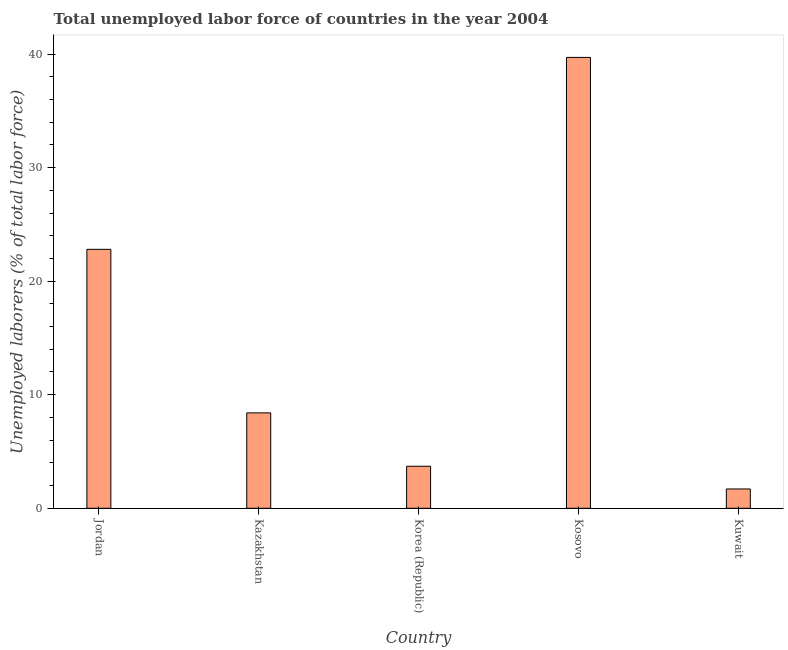What is the title of the graph?
Provide a short and direct response. Total unemployed labor force of countries in the year 2004. What is the label or title of the X-axis?
Provide a succinct answer. Country. What is the label or title of the Y-axis?
Keep it short and to the point. Unemployed laborers (% of total labor force). What is the total unemployed labour force in Kazakhstan?
Provide a succinct answer. 8.4. Across all countries, what is the maximum total unemployed labour force?
Make the answer very short. 39.7. Across all countries, what is the minimum total unemployed labour force?
Provide a short and direct response. 1.7. In which country was the total unemployed labour force maximum?
Your answer should be very brief. Kosovo. In which country was the total unemployed labour force minimum?
Your answer should be compact. Kuwait. What is the sum of the total unemployed labour force?
Offer a terse response. 76.3. What is the average total unemployed labour force per country?
Your answer should be compact. 15.26. What is the median total unemployed labour force?
Make the answer very short. 8.4. What is the ratio of the total unemployed labour force in Korea (Republic) to that in Kosovo?
Your answer should be very brief. 0.09. Is the difference between the total unemployed labour force in Kazakhstan and Kosovo greater than the difference between any two countries?
Make the answer very short. No. What is the difference between the highest and the second highest total unemployed labour force?
Offer a terse response. 16.9. Is the sum of the total unemployed labour force in Kosovo and Kuwait greater than the maximum total unemployed labour force across all countries?
Ensure brevity in your answer.  Yes. How many bars are there?
Offer a terse response. 5. Are all the bars in the graph horizontal?
Make the answer very short. No. What is the difference between two consecutive major ticks on the Y-axis?
Provide a short and direct response. 10. What is the Unemployed laborers (% of total labor force) of Jordan?
Offer a very short reply. 22.8. What is the Unemployed laborers (% of total labor force) in Kazakhstan?
Offer a very short reply. 8.4. What is the Unemployed laborers (% of total labor force) of Korea (Republic)?
Your response must be concise. 3.7. What is the Unemployed laborers (% of total labor force) in Kosovo?
Make the answer very short. 39.7. What is the Unemployed laborers (% of total labor force) in Kuwait?
Your response must be concise. 1.7. What is the difference between the Unemployed laborers (% of total labor force) in Jordan and Kosovo?
Provide a succinct answer. -16.9. What is the difference between the Unemployed laborers (% of total labor force) in Jordan and Kuwait?
Your answer should be compact. 21.1. What is the difference between the Unemployed laborers (% of total labor force) in Kazakhstan and Korea (Republic)?
Your answer should be compact. 4.7. What is the difference between the Unemployed laborers (% of total labor force) in Kazakhstan and Kosovo?
Give a very brief answer. -31.3. What is the difference between the Unemployed laborers (% of total labor force) in Kazakhstan and Kuwait?
Provide a short and direct response. 6.7. What is the difference between the Unemployed laborers (% of total labor force) in Korea (Republic) and Kosovo?
Your response must be concise. -36. What is the ratio of the Unemployed laborers (% of total labor force) in Jordan to that in Kazakhstan?
Your answer should be compact. 2.71. What is the ratio of the Unemployed laborers (% of total labor force) in Jordan to that in Korea (Republic)?
Your answer should be compact. 6.16. What is the ratio of the Unemployed laborers (% of total labor force) in Jordan to that in Kosovo?
Offer a terse response. 0.57. What is the ratio of the Unemployed laborers (% of total labor force) in Jordan to that in Kuwait?
Provide a short and direct response. 13.41. What is the ratio of the Unemployed laborers (% of total labor force) in Kazakhstan to that in Korea (Republic)?
Provide a short and direct response. 2.27. What is the ratio of the Unemployed laborers (% of total labor force) in Kazakhstan to that in Kosovo?
Your answer should be compact. 0.21. What is the ratio of the Unemployed laborers (% of total labor force) in Kazakhstan to that in Kuwait?
Offer a very short reply. 4.94. What is the ratio of the Unemployed laborers (% of total labor force) in Korea (Republic) to that in Kosovo?
Offer a terse response. 0.09. What is the ratio of the Unemployed laborers (% of total labor force) in Korea (Republic) to that in Kuwait?
Your answer should be compact. 2.18. What is the ratio of the Unemployed laborers (% of total labor force) in Kosovo to that in Kuwait?
Give a very brief answer. 23.35. 